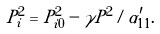Convert formula to latex. <formula><loc_0><loc_0><loc_500><loc_500>P _ { i } ^ { 2 } = P _ { i 0 } ^ { 2 } - \gamma P ^ { 2 } / \alpha ^ { \prime } _ { 1 1 } .</formula> 